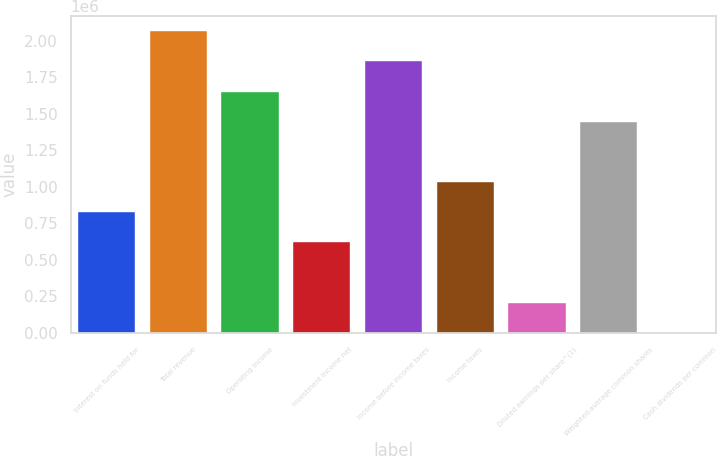Convert chart to OTSL. <chart><loc_0><loc_0><loc_500><loc_500><bar_chart><fcel>Interest on funds held for<fcel>Total revenue<fcel>Operating income<fcel>Investment income net<fcel>Income before income taxes<fcel>Income taxes<fcel>Diluted earnings per share^(1)<fcel>Weighted-average common shares<fcel>Cash dividends per common<nl><fcel>826530<fcel>2.06632e+06<fcel>1.65306e+06<fcel>619898<fcel>1.85969e+06<fcel>1.03316e+06<fcel>206633<fcel>1.44643e+06<fcel>1.2<nl></chart> 